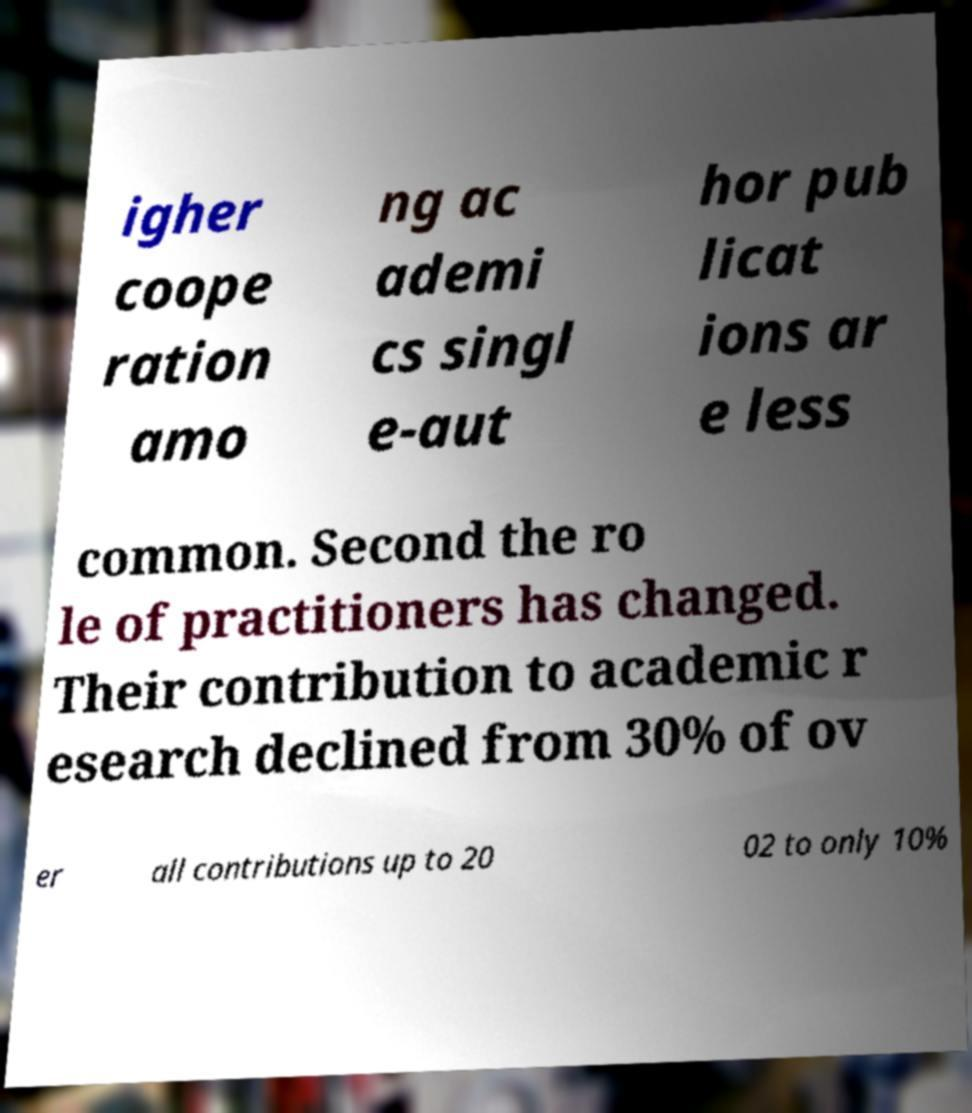Please read and relay the text visible in this image. What does it say? igher coope ration amo ng ac ademi cs singl e-aut hor pub licat ions ar e less common. Second the ro le of practitioners has changed. Their contribution to academic r esearch declined from 30% of ov er all contributions up to 20 02 to only 10% 